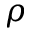<formula> <loc_0><loc_0><loc_500><loc_500>\rho</formula> 